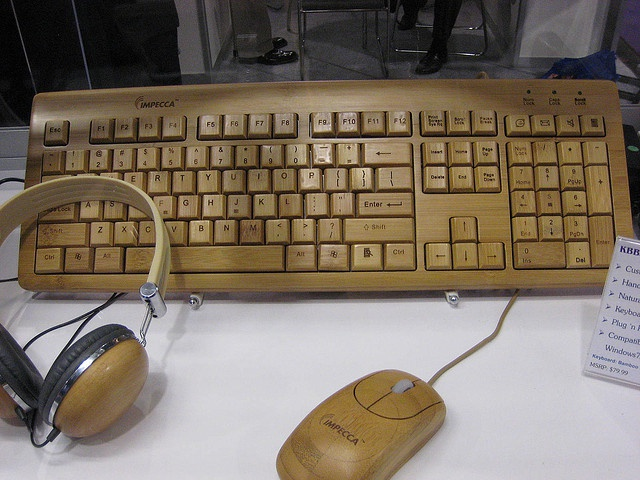Describe the objects in this image and their specific colors. I can see keyboard in black, olive, gray, and tan tones, mouse in black, olive, gray, and tan tones, people in black and gray tones, and people in black and gray tones in this image. 